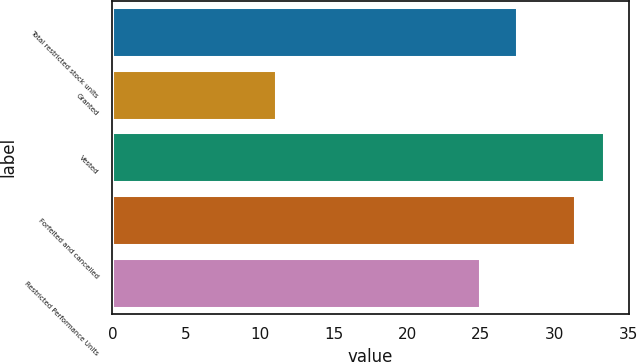Convert chart. <chart><loc_0><loc_0><loc_500><loc_500><bar_chart><fcel>Total restricted stock units<fcel>Granted<fcel>Vested<fcel>Forfeited and cancelled<fcel>Restricted Performance Units<nl><fcel>27.44<fcel>11.09<fcel>33.35<fcel>31.38<fcel>24.96<nl></chart> 